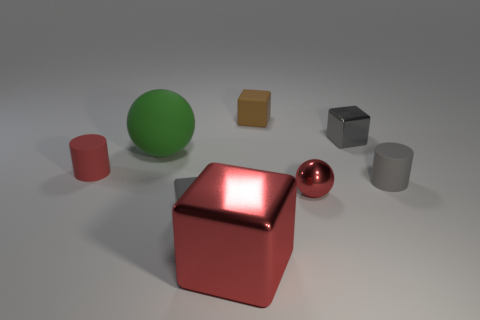Subtract all brown cylinders. How many gray blocks are left? 2 Subtract all red blocks. How many blocks are left? 3 Subtract all tiny brown cubes. How many cubes are left? 3 Add 1 large red things. How many objects exist? 9 Subtract all yellow cubes. Subtract all cyan cylinders. How many cubes are left? 4 Subtract all balls. How many objects are left? 6 Subtract 0 green cylinders. How many objects are left? 8 Subtract all small gray matte objects. Subtract all gray things. How many objects are left? 3 Add 6 big objects. How many big objects are left? 8 Add 5 gray shiny cubes. How many gray shiny cubes exist? 6 